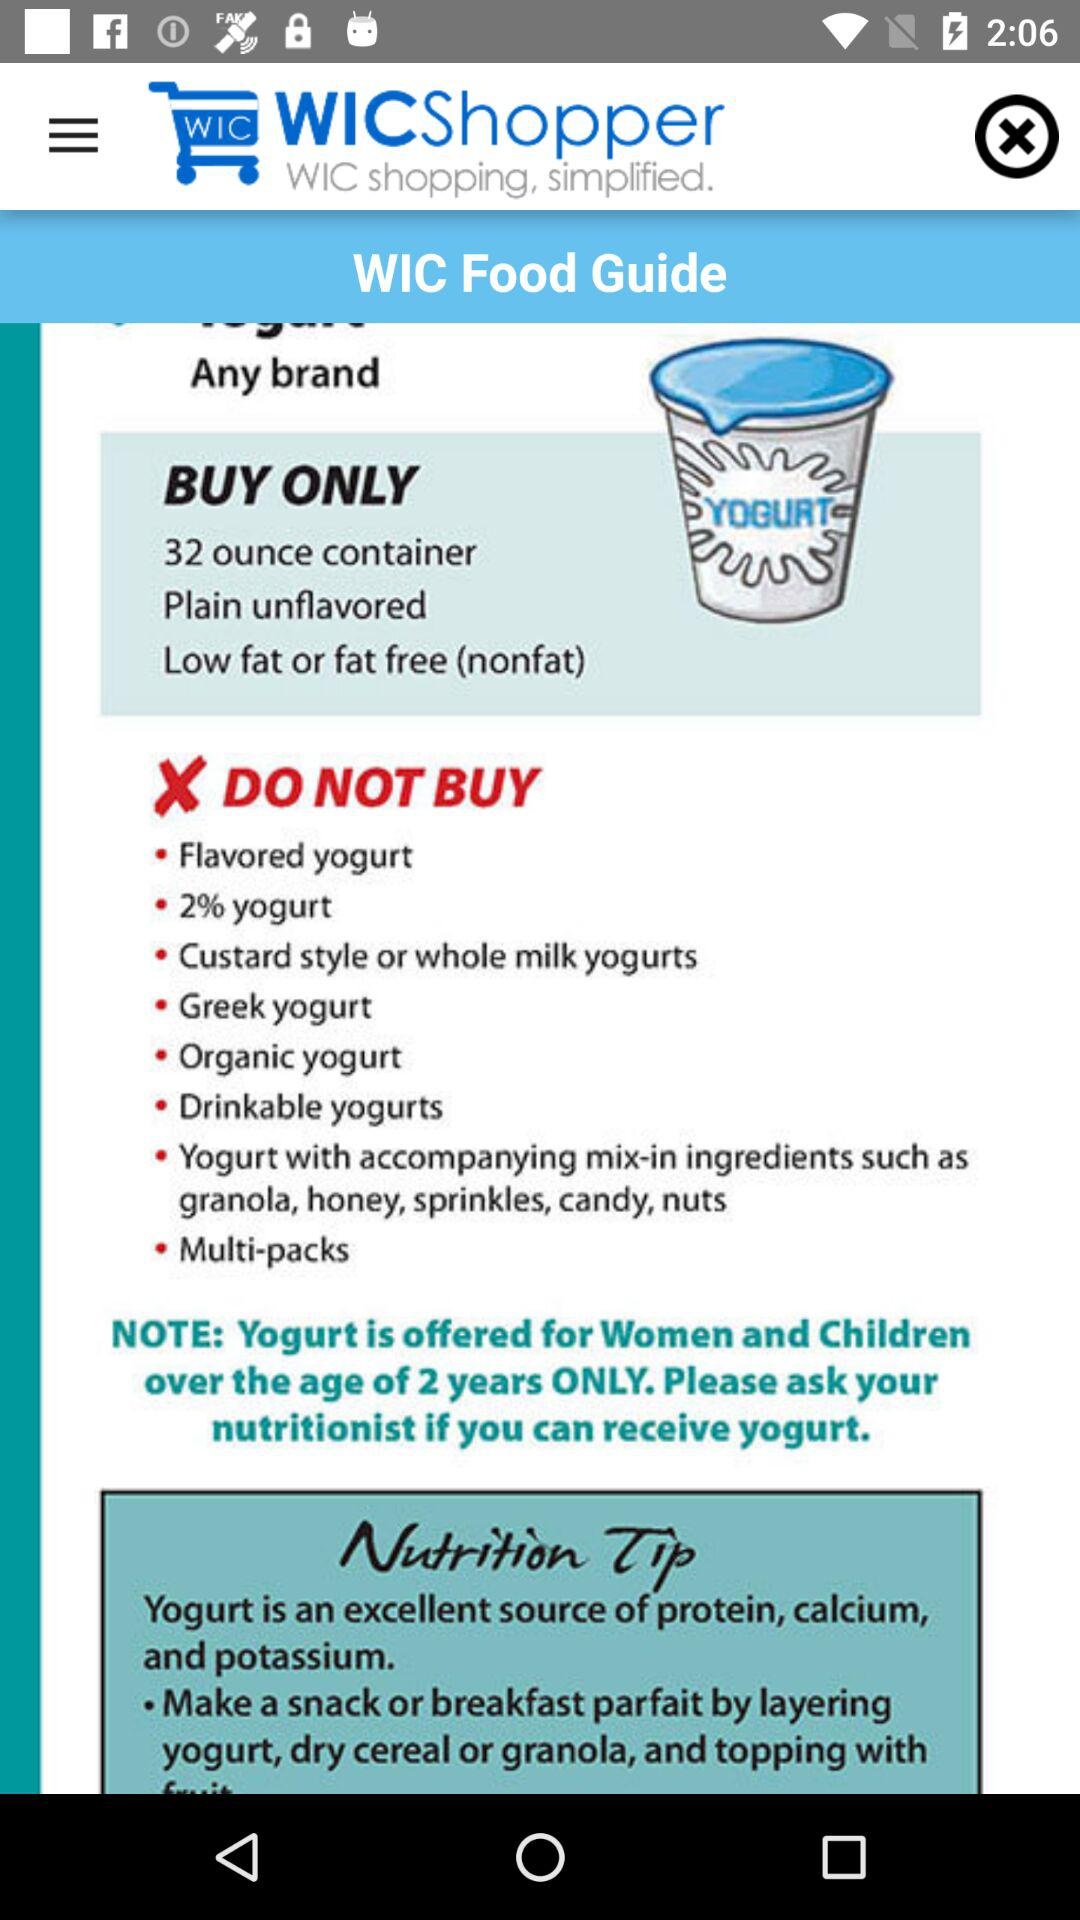What items need not be bought? The items are "Flavored yogurt", "2% yogurt", "Custard style or whole milk yogurts", "Greek yogurt", "Organic yogurt", "Drinkable yogurts", "Yogurt with accompanying mix-in ingredients such as granola, honey, sprinkles, candy, nuts" and "Multi-packs". 